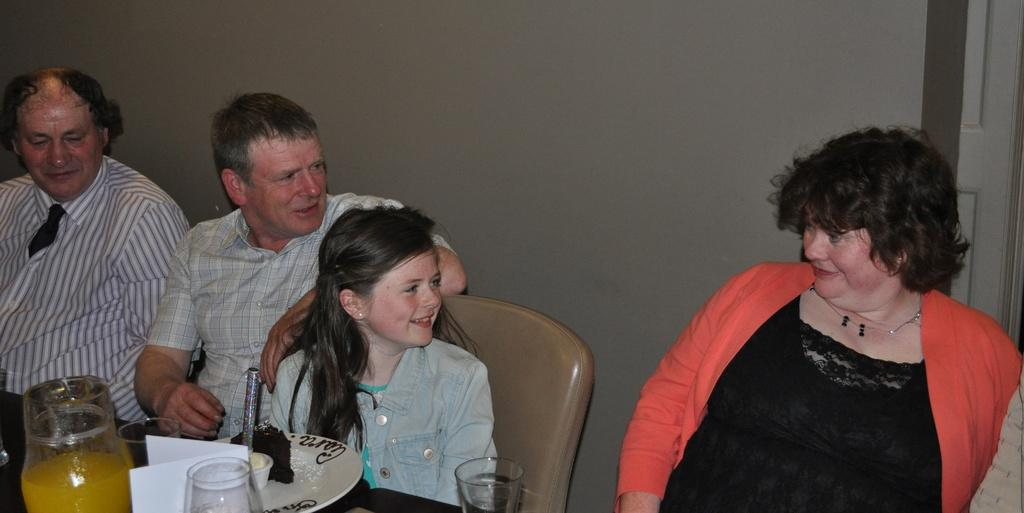What are the people in the image doing? There are persons sitting at the table in the image. What objects can be seen on the table? There is a jar, glasses, a plate, a cake, and a candle on the table. What is the purpose of the candle? The presence of a cake and a candle suggests that it might be a birthday celebration. What can be seen in the background of the image? There is a wall and a door in the background of the image. How does the cracker stretch across the table in the image? There is no cracker present in the image; it is not possible to answer this question based on the provided facts. 